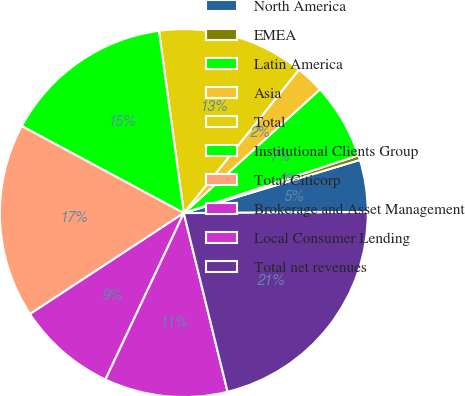<chart> <loc_0><loc_0><loc_500><loc_500><pie_chart><fcel>North America<fcel>EMEA<fcel>Latin America<fcel>Asia<fcel>Total<fcel>Institutional Clients Group<fcel>Total Citicorp<fcel>Brokerage and Asset Management<fcel>Local Consumer Lending<fcel>Total net revenues<nl><fcel>4.58%<fcel>0.41%<fcel>6.66%<fcel>2.5%<fcel>12.92%<fcel>15.0%<fcel>17.09%<fcel>8.75%<fcel>10.83%<fcel>21.26%<nl></chart> 